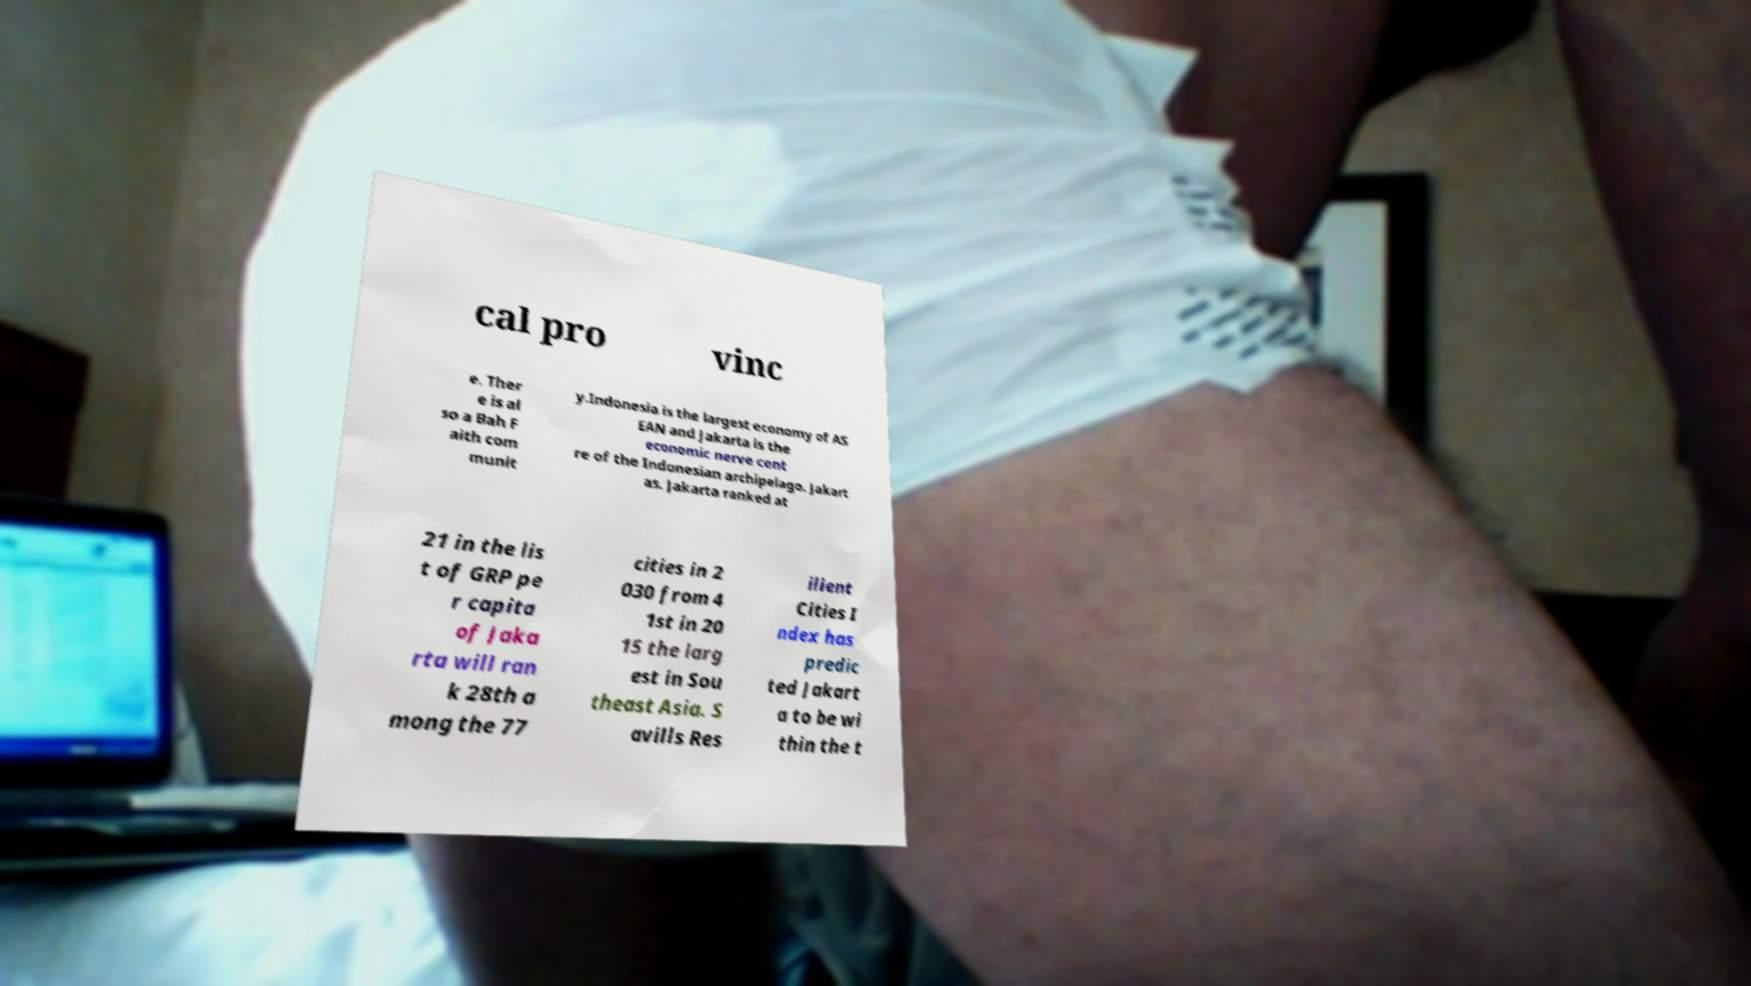There's text embedded in this image that I need extracted. Can you transcribe it verbatim? cal pro vinc e. Ther e is al so a Bah F aith com munit y.Indonesia is the largest economy of AS EAN and Jakarta is the economic nerve cent re of the Indonesian archipelago. Jakart as. Jakarta ranked at 21 in the lis t of GRP pe r capita of Jaka rta will ran k 28th a mong the 77 cities in 2 030 from 4 1st in 20 15 the larg est in Sou theast Asia. S avills Res ilient Cities I ndex has predic ted Jakart a to be wi thin the t 